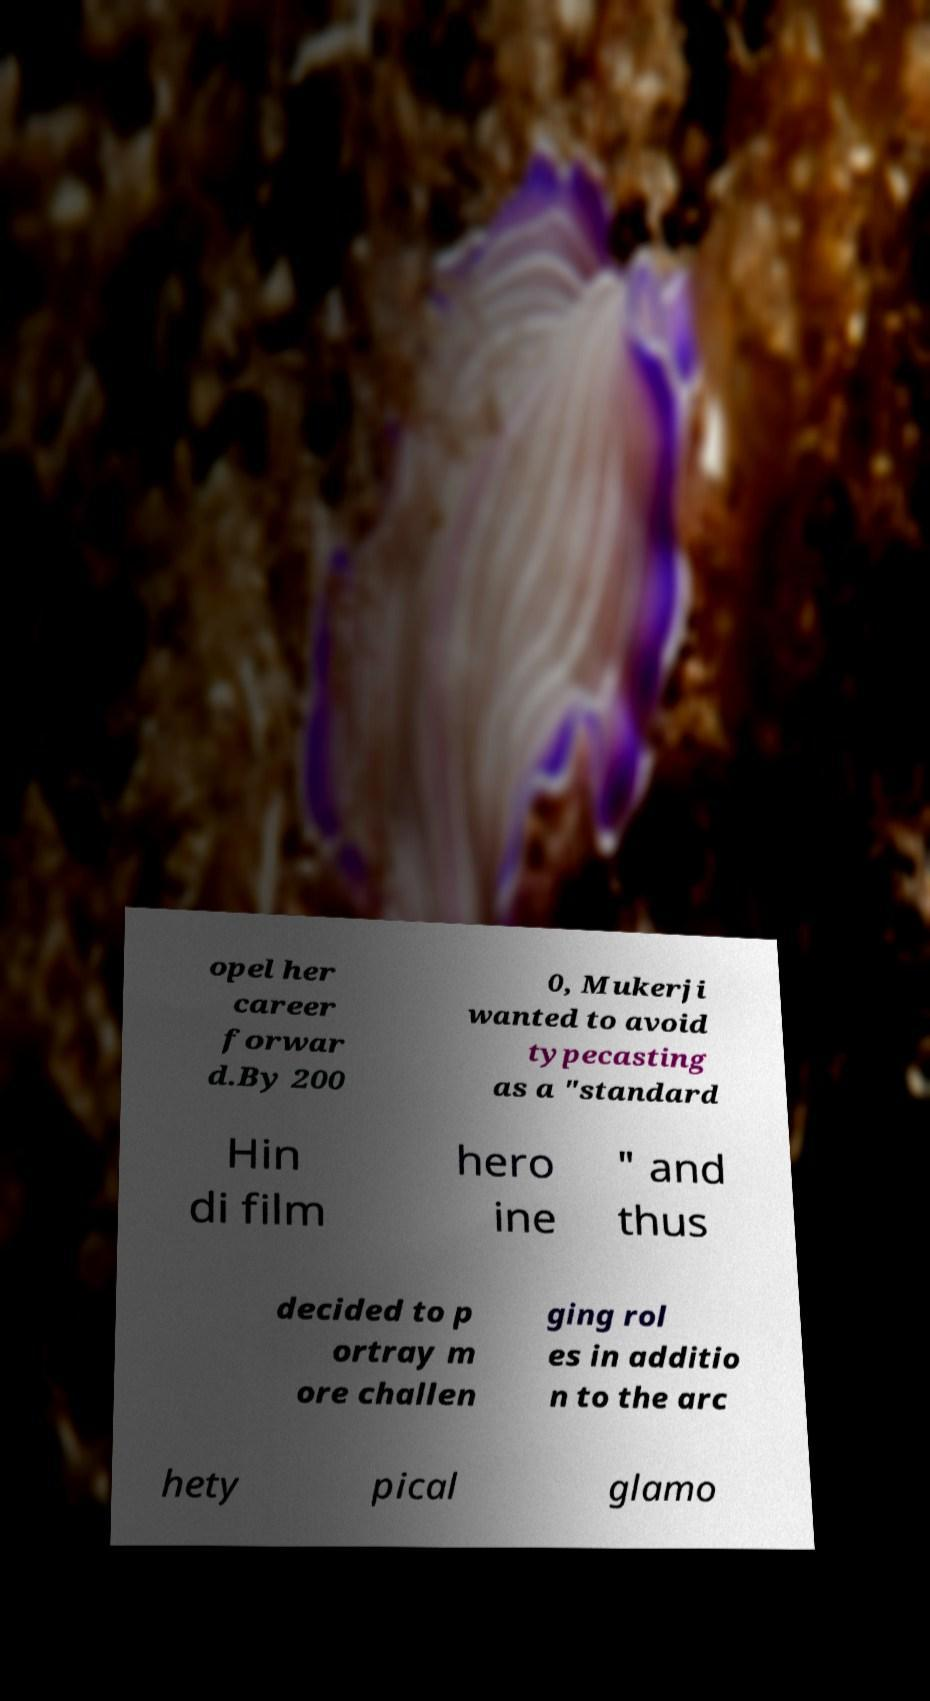Can you accurately transcribe the text from the provided image for me? opel her career forwar d.By 200 0, Mukerji wanted to avoid typecasting as a "standard Hin di film hero ine " and thus decided to p ortray m ore challen ging rol es in additio n to the arc hety pical glamo 